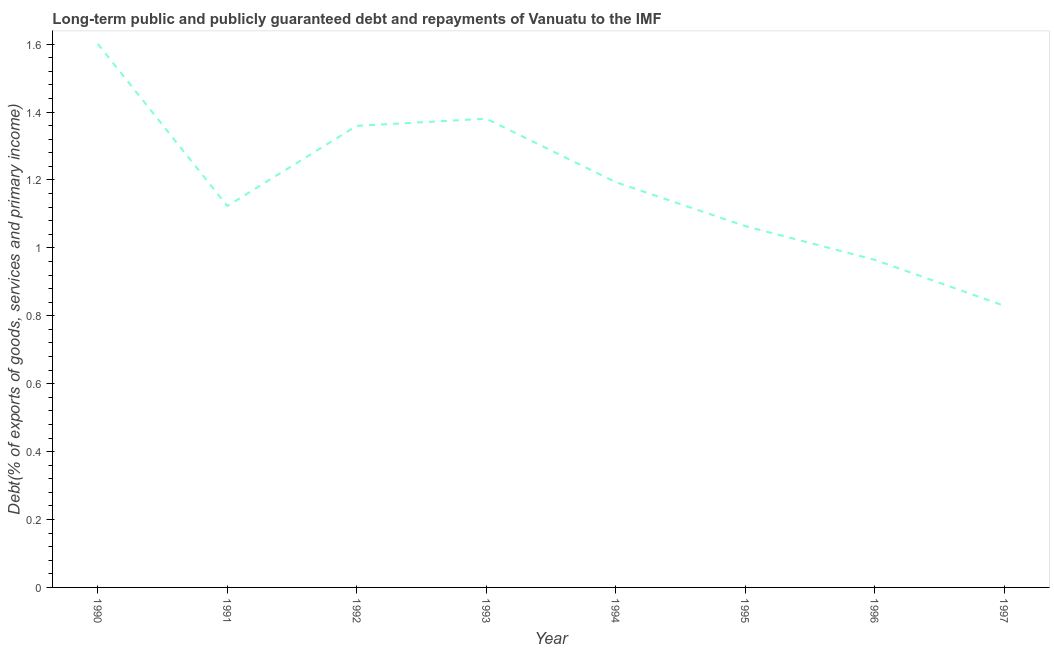What is the debt service in 1992?
Your answer should be very brief. 1.36. Across all years, what is the maximum debt service?
Ensure brevity in your answer.  1.6. Across all years, what is the minimum debt service?
Your response must be concise. 0.83. In which year was the debt service maximum?
Offer a terse response. 1990. What is the sum of the debt service?
Your answer should be compact. 9.52. What is the difference between the debt service in 1991 and 1992?
Give a very brief answer. -0.24. What is the average debt service per year?
Provide a short and direct response. 1.19. What is the median debt service?
Keep it short and to the point. 1.16. Do a majority of the years between 1993 and 1997 (inclusive) have debt service greater than 1.16 %?
Offer a very short reply. No. What is the ratio of the debt service in 1991 to that in 1995?
Make the answer very short. 1.06. What is the difference between the highest and the second highest debt service?
Make the answer very short. 0.22. Is the sum of the debt service in 1990 and 1991 greater than the maximum debt service across all years?
Provide a succinct answer. Yes. What is the difference between the highest and the lowest debt service?
Your response must be concise. 0.77. Does the debt service monotonically increase over the years?
Your answer should be compact. No. How many lines are there?
Keep it short and to the point. 1. How many years are there in the graph?
Offer a very short reply. 8. Are the values on the major ticks of Y-axis written in scientific E-notation?
Offer a very short reply. No. What is the title of the graph?
Give a very brief answer. Long-term public and publicly guaranteed debt and repayments of Vanuatu to the IMF. What is the label or title of the X-axis?
Offer a very short reply. Year. What is the label or title of the Y-axis?
Your answer should be very brief. Debt(% of exports of goods, services and primary income). What is the Debt(% of exports of goods, services and primary income) in 1990?
Provide a succinct answer. 1.6. What is the Debt(% of exports of goods, services and primary income) of 1991?
Make the answer very short. 1.12. What is the Debt(% of exports of goods, services and primary income) in 1992?
Ensure brevity in your answer.  1.36. What is the Debt(% of exports of goods, services and primary income) in 1993?
Provide a succinct answer. 1.38. What is the Debt(% of exports of goods, services and primary income) in 1994?
Keep it short and to the point. 1.19. What is the Debt(% of exports of goods, services and primary income) of 1995?
Your answer should be compact. 1.06. What is the Debt(% of exports of goods, services and primary income) of 1996?
Your answer should be compact. 0.96. What is the Debt(% of exports of goods, services and primary income) of 1997?
Your response must be concise. 0.83. What is the difference between the Debt(% of exports of goods, services and primary income) in 1990 and 1991?
Ensure brevity in your answer.  0.48. What is the difference between the Debt(% of exports of goods, services and primary income) in 1990 and 1992?
Offer a very short reply. 0.24. What is the difference between the Debt(% of exports of goods, services and primary income) in 1990 and 1993?
Make the answer very short. 0.22. What is the difference between the Debt(% of exports of goods, services and primary income) in 1990 and 1994?
Your answer should be very brief. 0.41. What is the difference between the Debt(% of exports of goods, services and primary income) in 1990 and 1995?
Provide a short and direct response. 0.54. What is the difference between the Debt(% of exports of goods, services and primary income) in 1990 and 1996?
Your answer should be compact. 0.64. What is the difference between the Debt(% of exports of goods, services and primary income) in 1990 and 1997?
Ensure brevity in your answer.  0.77. What is the difference between the Debt(% of exports of goods, services and primary income) in 1991 and 1992?
Your answer should be very brief. -0.24. What is the difference between the Debt(% of exports of goods, services and primary income) in 1991 and 1993?
Your answer should be very brief. -0.26. What is the difference between the Debt(% of exports of goods, services and primary income) in 1991 and 1994?
Offer a terse response. -0.07. What is the difference between the Debt(% of exports of goods, services and primary income) in 1991 and 1995?
Your answer should be compact. 0.06. What is the difference between the Debt(% of exports of goods, services and primary income) in 1991 and 1996?
Offer a very short reply. 0.16. What is the difference between the Debt(% of exports of goods, services and primary income) in 1991 and 1997?
Offer a terse response. 0.29. What is the difference between the Debt(% of exports of goods, services and primary income) in 1992 and 1993?
Keep it short and to the point. -0.02. What is the difference between the Debt(% of exports of goods, services and primary income) in 1992 and 1994?
Provide a succinct answer. 0.17. What is the difference between the Debt(% of exports of goods, services and primary income) in 1992 and 1995?
Your response must be concise. 0.3. What is the difference between the Debt(% of exports of goods, services and primary income) in 1992 and 1996?
Your answer should be compact. 0.39. What is the difference between the Debt(% of exports of goods, services and primary income) in 1992 and 1997?
Your response must be concise. 0.53. What is the difference between the Debt(% of exports of goods, services and primary income) in 1993 and 1994?
Your answer should be compact. 0.19. What is the difference between the Debt(% of exports of goods, services and primary income) in 1993 and 1995?
Your response must be concise. 0.32. What is the difference between the Debt(% of exports of goods, services and primary income) in 1993 and 1996?
Your answer should be very brief. 0.42. What is the difference between the Debt(% of exports of goods, services and primary income) in 1993 and 1997?
Your answer should be compact. 0.55. What is the difference between the Debt(% of exports of goods, services and primary income) in 1994 and 1995?
Your response must be concise. 0.13. What is the difference between the Debt(% of exports of goods, services and primary income) in 1994 and 1996?
Make the answer very short. 0.23. What is the difference between the Debt(% of exports of goods, services and primary income) in 1994 and 1997?
Offer a very short reply. 0.36. What is the difference between the Debt(% of exports of goods, services and primary income) in 1995 and 1996?
Make the answer very short. 0.1. What is the difference between the Debt(% of exports of goods, services and primary income) in 1995 and 1997?
Ensure brevity in your answer.  0.23. What is the difference between the Debt(% of exports of goods, services and primary income) in 1996 and 1997?
Keep it short and to the point. 0.14. What is the ratio of the Debt(% of exports of goods, services and primary income) in 1990 to that in 1991?
Provide a short and direct response. 1.43. What is the ratio of the Debt(% of exports of goods, services and primary income) in 1990 to that in 1992?
Your answer should be compact. 1.18. What is the ratio of the Debt(% of exports of goods, services and primary income) in 1990 to that in 1993?
Provide a succinct answer. 1.16. What is the ratio of the Debt(% of exports of goods, services and primary income) in 1990 to that in 1994?
Your answer should be very brief. 1.34. What is the ratio of the Debt(% of exports of goods, services and primary income) in 1990 to that in 1995?
Offer a terse response. 1.5. What is the ratio of the Debt(% of exports of goods, services and primary income) in 1990 to that in 1996?
Your answer should be compact. 1.66. What is the ratio of the Debt(% of exports of goods, services and primary income) in 1990 to that in 1997?
Make the answer very short. 1.93. What is the ratio of the Debt(% of exports of goods, services and primary income) in 1991 to that in 1992?
Your answer should be very brief. 0.83. What is the ratio of the Debt(% of exports of goods, services and primary income) in 1991 to that in 1993?
Ensure brevity in your answer.  0.81. What is the ratio of the Debt(% of exports of goods, services and primary income) in 1991 to that in 1994?
Provide a succinct answer. 0.94. What is the ratio of the Debt(% of exports of goods, services and primary income) in 1991 to that in 1995?
Offer a terse response. 1.06. What is the ratio of the Debt(% of exports of goods, services and primary income) in 1991 to that in 1996?
Make the answer very short. 1.16. What is the ratio of the Debt(% of exports of goods, services and primary income) in 1991 to that in 1997?
Provide a succinct answer. 1.35. What is the ratio of the Debt(% of exports of goods, services and primary income) in 1992 to that in 1993?
Make the answer very short. 0.98. What is the ratio of the Debt(% of exports of goods, services and primary income) in 1992 to that in 1994?
Provide a short and direct response. 1.14. What is the ratio of the Debt(% of exports of goods, services and primary income) in 1992 to that in 1995?
Your answer should be very brief. 1.28. What is the ratio of the Debt(% of exports of goods, services and primary income) in 1992 to that in 1996?
Your answer should be very brief. 1.41. What is the ratio of the Debt(% of exports of goods, services and primary income) in 1992 to that in 1997?
Give a very brief answer. 1.64. What is the ratio of the Debt(% of exports of goods, services and primary income) in 1993 to that in 1994?
Provide a short and direct response. 1.16. What is the ratio of the Debt(% of exports of goods, services and primary income) in 1993 to that in 1995?
Make the answer very short. 1.3. What is the ratio of the Debt(% of exports of goods, services and primary income) in 1993 to that in 1996?
Ensure brevity in your answer.  1.43. What is the ratio of the Debt(% of exports of goods, services and primary income) in 1993 to that in 1997?
Keep it short and to the point. 1.66. What is the ratio of the Debt(% of exports of goods, services and primary income) in 1994 to that in 1995?
Keep it short and to the point. 1.12. What is the ratio of the Debt(% of exports of goods, services and primary income) in 1994 to that in 1996?
Offer a very short reply. 1.24. What is the ratio of the Debt(% of exports of goods, services and primary income) in 1994 to that in 1997?
Provide a succinct answer. 1.44. What is the ratio of the Debt(% of exports of goods, services and primary income) in 1995 to that in 1996?
Your response must be concise. 1.1. What is the ratio of the Debt(% of exports of goods, services and primary income) in 1995 to that in 1997?
Provide a succinct answer. 1.28. What is the ratio of the Debt(% of exports of goods, services and primary income) in 1996 to that in 1997?
Give a very brief answer. 1.16. 